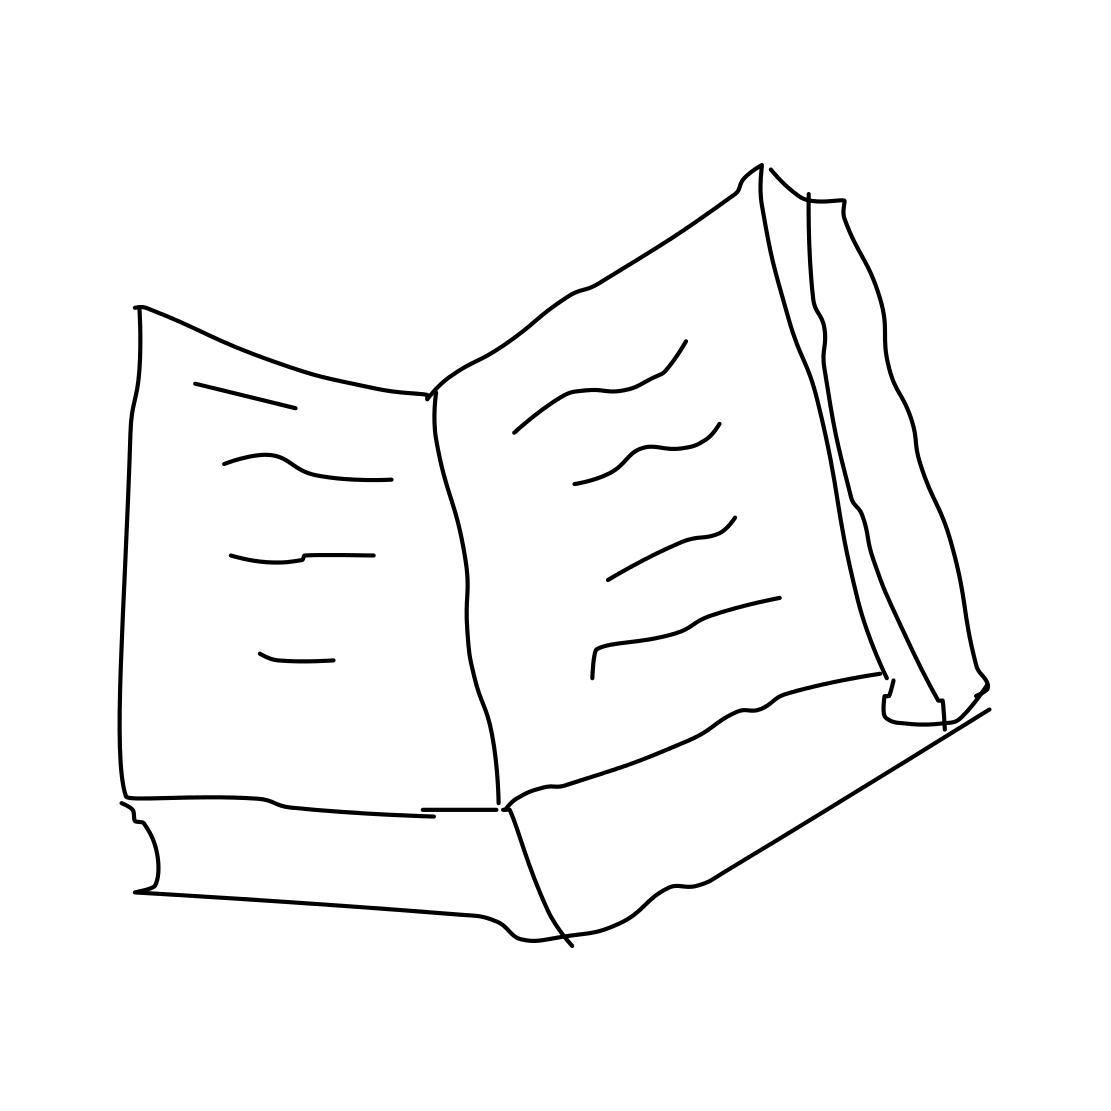Could this book be used for educational purposes? Certainly! The drawing of the book with its open pages suggests it might be a textbook or reference material, ideal for learning about a particular subject. 